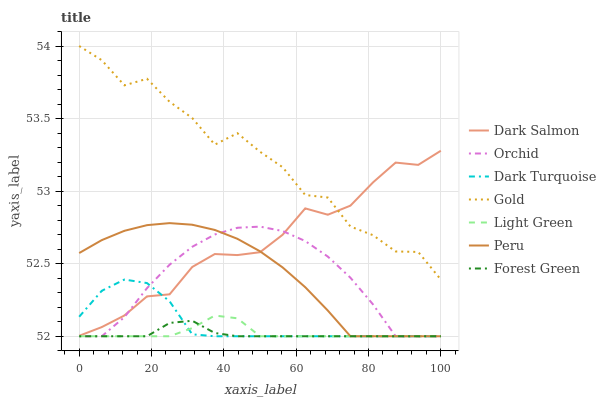Does Forest Green have the minimum area under the curve?
Answer yes or no. Yes. Does Gold have the maximum area under the curve?
Answer yes or no. Yes. Does Dark Turquoise have the minimum area under the curve?
Answer yes or no. No. Does Dark Turquoise have the maximum area under the curve?
Answer yes or no. No. Is Forest Green the smoothest?
Answer yes or no. Yes. Is Gold the roughest?
Answer yes or no. Yes. Is Dark Turquoise the smoothest?
Answer yes or no. No. Is Dark Turquoise the roughest?
Answer yes or no. No. Does Light Green have the lowest value?
Answer yes or no. Yes. Does Gold have the lowest value?
Answer yes or no. No. Does Gold have the highest value?
Answer yes or no. Yes. Does Dark Turquoise have the highest value?
Answer yes or no. No. Is Dark Turquoise less than Gold?
Answer yes or no. Yes. Is Gold greater than Forest Green?
Answer yes or no. Yes. Does Dark Salmon intersect Gold?
Answer yes or no. Yes. Is Dark Salmon less than Gold?
Answer yes or no. No. Is Dark Salmon greater than Gold?
Answer yes or no. No. Does Dark Turquoise intersect Gold?
Answer yes or no. No. 